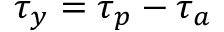<formula> <loc_0><loc_0><loc_500><loc_500>\tau _ { y } = \tau _ { p } - \tau _ { a }</formula> 